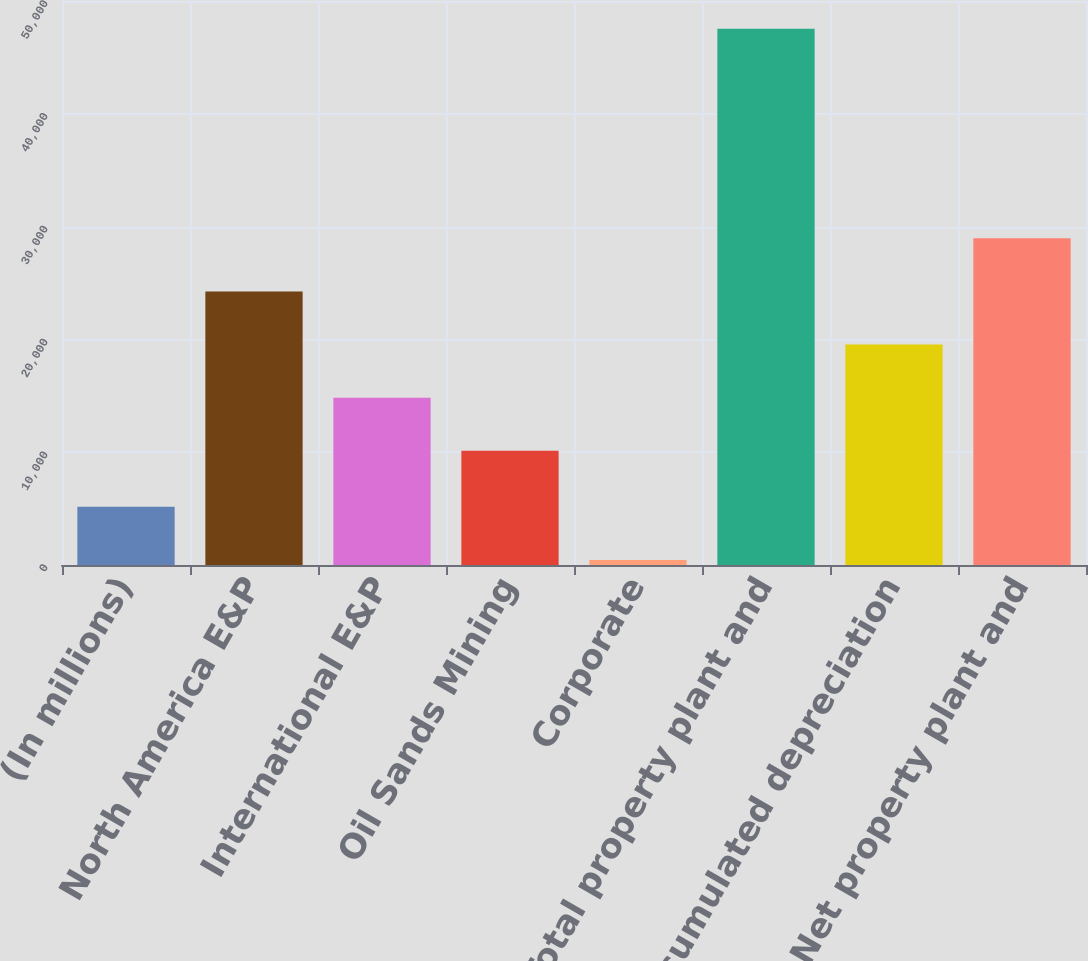<chart> <loc_0><loc_0><loc_500><loc_500><bar_chart><fcel>(In millions)<fcel>North America E&P<fcel>International E&P<fcel>Oil Sands Mining<fcel>Corporate<fcel>Total property plant and<fcel>Less accumulated depreciation<fcel>Net property plant and<nl><fcel>5157.9<fcel>24253.7<fcel>14835.9<fcel>10127<fcel>449<fcel>47538<fcel>19544.8<fcel>28962.6<nl></chart> 